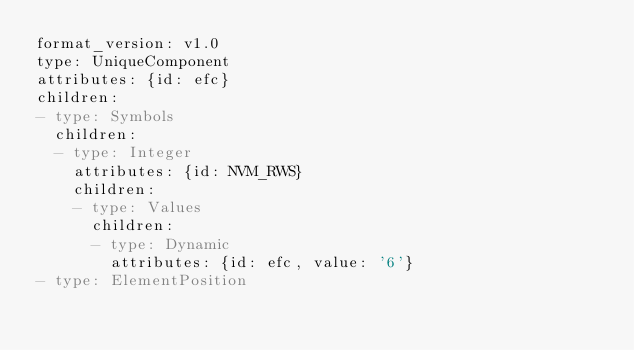<code> <loc_0><loc_0><loc_500><loc_500><_YAML_>format_version: v1.0
type: UniqueComponent
attributes: {id: efc}
children:
- type: Symbols
  children:
  - type: Integer
    attributes: {id: NVM_RWS}
    children:
    - type: Values
      children:
      - type: Dynamic
        attributes: {id: efc, value: '6'}
- type: ElementPosition</code> 